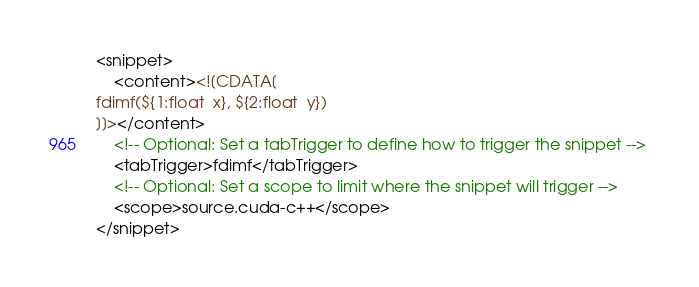<code> <loc_0><loc_0><loc_500><loc_500><_XML_><snippet> 
	<content><![CDATA[
fdimf(${1:float  x}, ${2:float  y})
]]></content> 
	<!-- Optional: Set a tabTrigger to define how to trigger the snippet --> 
	<tabTrigger>fdimf</tabTrigger> 
	<!-- Optional: Set a scope to limit where the snippet will trigger --> 
	<scope>source.cuda-c++</scope> 
</snippet></code> 